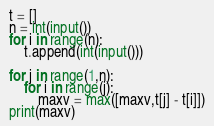Convert code to text. <code><loc_0><loc_0><loc_500><loc_500><_Python_>t = []
n = int(input())
for i in range(n):
    t.append(int(input()))

for j in range(1,n):
    for i in range(j):
        maxv = max([maxv,t[j] - t[i]])
print(maxv)</code> 